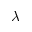Convert formula to latex. <formula><loc_0><loc_0><loc_500><loc_500>\lambda</formula> 